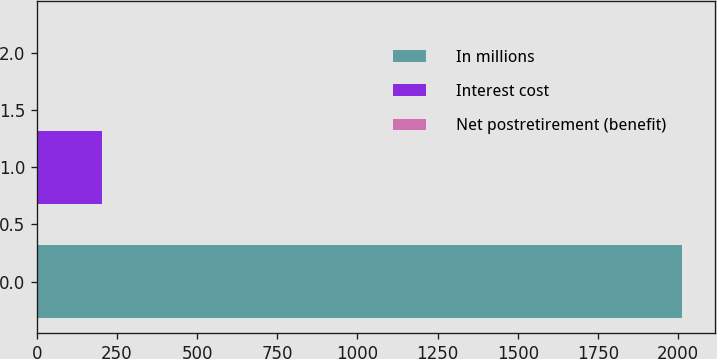Convert chart. <chart><loc_0><loc_0><loc_500><loc_500><bar_chart><fcel>In millions<fcel>Interest cost<fcel>Net postretirement (benefit)<nl><fcel>2013<fcel>202.2<fcel>1<nl></chart> 